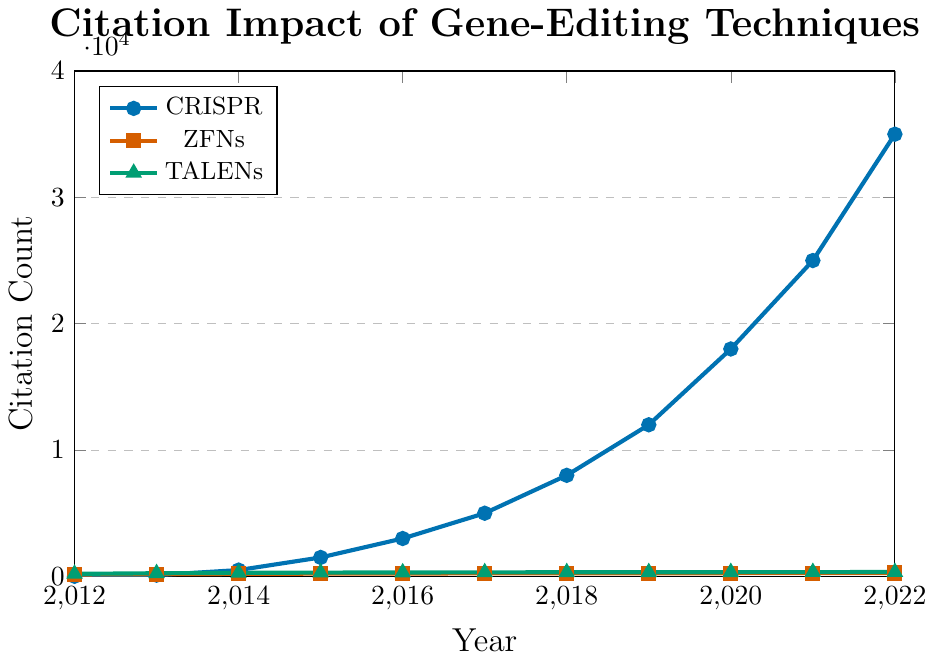What was the citation count for CRISPR in 2016? To find the citation count for CRISPR in 2016, locate the point on the CRISPR line plot that corresponds to the year 2016. The y-axis value at this point is the citation count.
Answer: 3000 In which year did CRISPR first surpass 10,000 citations? To determine the year when CRISPR citation count surpasses 10,000, look for the first point on the CRISPR line where the y-axis value exceeds 10,000. This occurs in 2019.
Answer: 2019 How much did the citation count for TALENs increase from 2012 to 2022? To find the increase in TALENs citations, subtract the 2012 citation count from the 2022 citation count for TALENs. This is 345 - 200.
Answer: 145 Which year saw the highest citation increase for CRISPR between consecutive years? To determine the year with the highest citation increase for CRISPR, calculate the differences between consecutive years and find the maximum. The largest increase from 2019 to 2020 (18000 - 12000 = 6000).
Answer: 2019 to 2020 Compare the citation counts of ZFNs and TALENs in 2020. Which one is higher and by how much? Evaluate the citation counts for ZFNs and TALENs in 2020, then subtract the count for ZFNs from that of TALENs. TALENs: 335, ZFNs: 255, Difference: 335 - 255.
Answer: TALENs, 80 What is the average annual growth in citations for CRISPR from 2012 to 2022? Compute the total growth in CRISPR citations from 2012 (10) to 2022 (35000), and then divide by the number of years (2022-2012). (35000 - 10) / 10 = 3499.
Answer: 3499 By how much did CRISPR citations increase between 2017 and 2018? To find the increase, subtract the CRISPR citation count in 2017 from that in 2018. This is 8000 - 5000.
Answer: 3000 When did CRISPR citations surpass ZFNs and by how much in that year? Identify the year when CRISPR citations first surpassed ZFNs, which is 2013. Subtract ZFNs from CRISPR citations for that year (100 - 180) = -80; CRISPR only surpasses in 2014 (500-200).
Answer: 2014, 300 What is the trend in citation count for TALENs between 2012 and 2022? Observe the plot for TALENs and summarize the trend. The line remains relatively flat, indicating a small steady increase with no major surges.
Answer: Steady, small increase Compare the citation growth rates of all three techniques. Which one shows a dramatic growth and which ones are relatively stable? By examining the slopes of the lines, CRISPR shows dramatic growth with a steep upward trend. ZFNs and TALENs exhibit relatively stable, mild upward trends with much smaller slope angles.
Answer: CRISPR dramatic, ZFNs and TALENs stable 